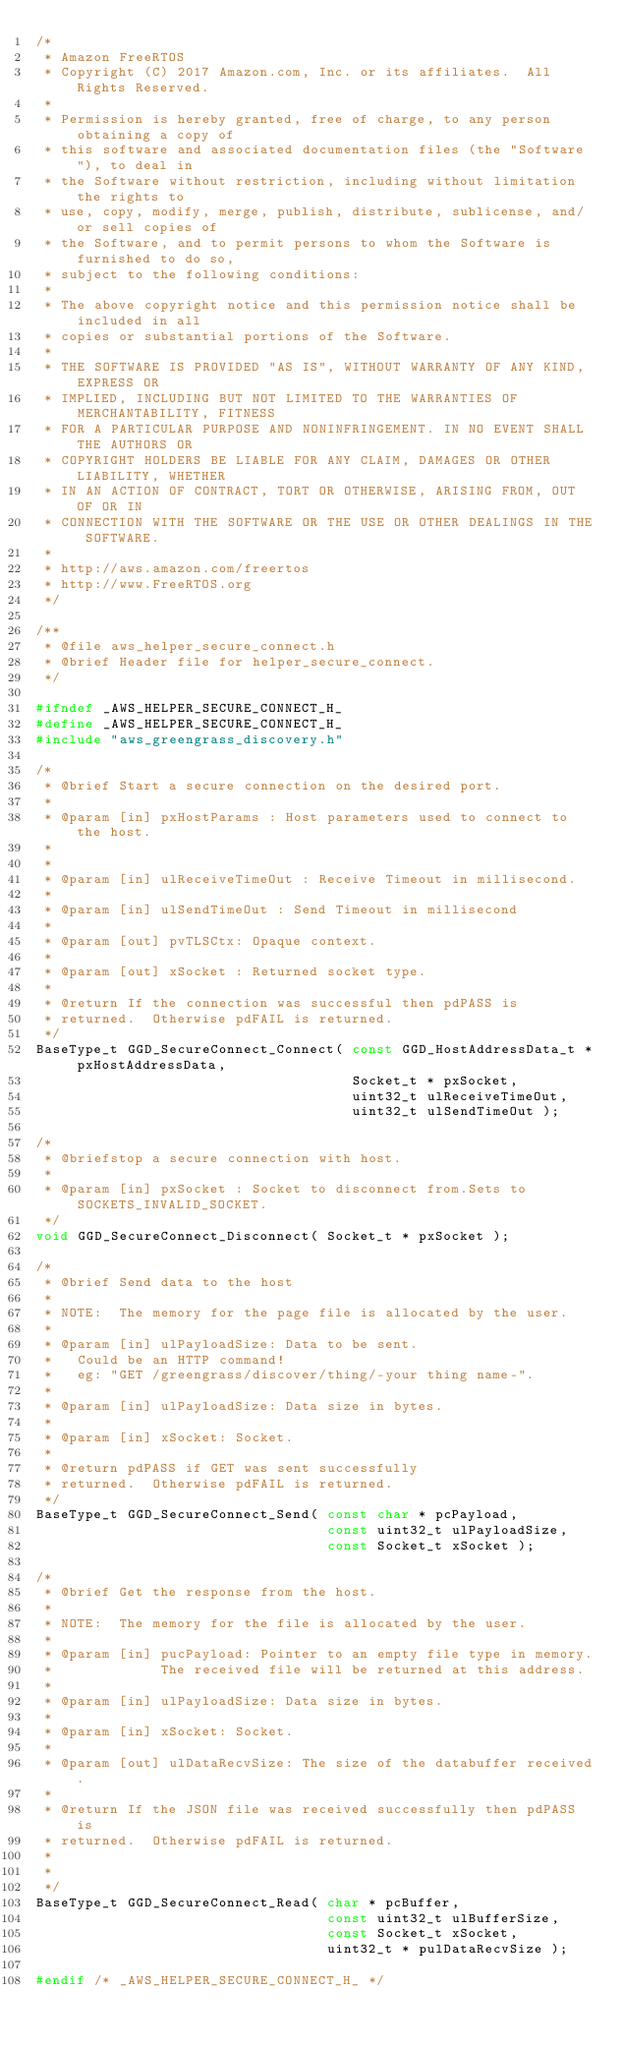Convert code to text. <code><loc_0><loc_0><loc_500><loc_500><_C_>/*
 * Amazon FreeRTOS
 * Copyright (C) 2017 Amazon.com, Inc. or its affiliates.  All Rights Reserved.
 *
 * Permission is hereby granted, free of charge, to any person obtaining a copy of
 * this software and associated documentation files (the "Software"), to deal in
 * the Software without restriction, including without limitation the rights to
 * use, copy, modify, merge, publish, distribute, sublicense, and/or sell copies of
 * the Software, and to permit persons to whom the Software is furnished to do so,
 * subject to the following conditions:
 *
 * The above copyright notice and this permission notice shall be included in all
 * copies or substantial portions of the Software.
 *
 * THE SOFTWARE IS PROVIDED "AS IS", WITHOUT WARRANTY OF ANY KIND, EXPRESS OR
 * IMPLIED, INCLUDING BUT NOT LIMITED TO THE WARRANTIES OF MERCHANTABILITY, FITNESS
 * FOR A PARTICULAR PURPOSE AND NONINFRINGEMENT. IN NO EVENT SHALL THE AUTHORS OR
 * COPYRIGHT HOLDERS BE LIABLE FOR ANY CLAIM, DAMAGES OR OTHER LIABILITY, WHETHER
 * IN AN ACTION OF CONTRACT, TORT OR OTHERWISE, ARISING FROM, OUT OF OR IN
 * CONNECTION WITH THE SOFTWARE OR THE USE OR OTHER DEALINGS IN THE SOFTWARE.
 *
 * http://aws.amazon.com/freertos
 * http://www.FreeRTOS.org
 */

/**
 * @file aws_helper_secure_connect.h
 * @brief Header file for helper_secure_connect.
 */

#ifndef _AWS_HELPER_SECURE_CONNECT_H_
#define _AWS_HELPER_SECURE_CONNECT_H_
#include "aws_greengrass_discovery.h"

/*
 * @brief Start a secure connection on the desired port.
 *
 * @param [in] pxHostParams : Host parameters used to connect to the host.
 *
 *
 * @param [in] ulReceiveTimeOut : Receive Timeout in millisecond.
 *
 * @param [in] ulSendTimeOut : Send Timeout in millisecond
 *
 * @param [out] pvTLSCtx: Opaque context.
 *
 * @param [out] xSocket : Returned socket type.
 *
 * @return If the connection was successful then pdPASS is
 * returned.  Otherwise pdFAIL is returned.
 */
BaseType_t GGD_SecureConnect_Connect( const GGD_HostAddressData_t * pxHostAddressData,
                                      Socket_t * pxSocket,
                                      uint32_t ulReceiveTimeOut,
                                      uint32_t ulSendTimeOut );

/*
 * @briefstop a secure connection with host.
 *
 * @param [in] pxSocket : Socket to disconnect from.Sets to SOCKETS_INVALID_SOCKET.
 */
void GGD_SecureConnect_Disconnect( Socket_t * pxSocket );

/*
 * @brief Send data to the host
 *
 * NOTE:  The memory for the page file is allocated by the user.
 *
 * @param [in] ulPayloadSize: Data to be sent.
 *   Could be an HTTP command!
 *   eg: "GET /greengrass/discover/thing/-your thing name-".
 *
 * @param [in] ulPayloadSize: Data size in bytes.
 *
 * @param [in] xSocket: Socket.
 *
 * @return pdPASS if GET was sent successfully
 * returned.  Otherwise pdFAIL is returned.
 */
BaseType_t GGD_SecureConnect_Send( const char * pcPayload,
                                   const uint32_t ulPayloadSize,
                                   const Socket_t xSocket );

/*
 * @brief Get the response from the host.
 *
 * NOTE:  The memory for the file is allocated by the user.
 *
 * @param [in] pucPayload: Pointer to an empty file type in memory.
 *             The received file will be returned at this address.
 *
 * @param [in] ulPayloadSize: Data size in bytes.
 *
 * @param [in] xSocket: Socket.
 *
 * @param [out] ulDataRecvSize: The size of the databuffer received.
 *
 * @return If the JSON file was received successfully then pdPASS is
 * returned.  Otherwise pdFAIL is returned.
 *
 *
 */
BaseType_t GGD_SecureConnect_Read( char * pcBuffer,
                                   const uint32_t ulBufferSize,
                                   const Socket_t xSocket,
                                   uint32_t * pulDataRecvSize );

#endif /* _AWS_HELPER_SECURE_CONNECT_H_ */
</code> 